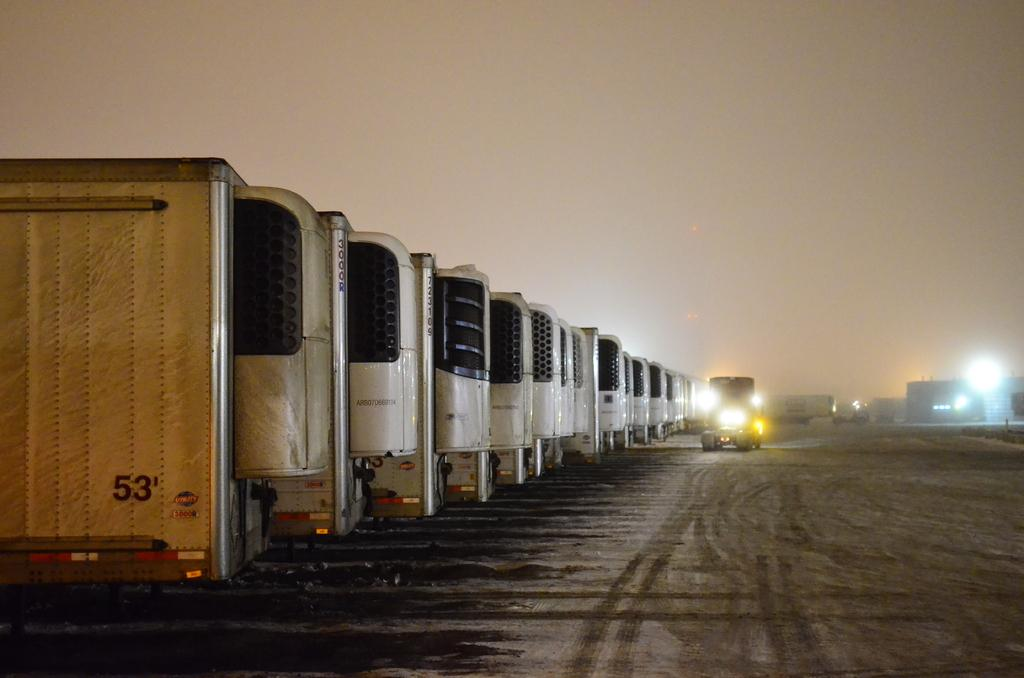What type of vehicles can be seen in the image? There are trucks in the image. What can be seen in the distance behind the trucks? There are buildings and lights in the background of the image. What is visible at the top of the image? The sky is visible at the top of the image. What type of terrain is at the bottom of the image? There is sand at the bottom of the image. What type of quill is being used to write on the sand in the image? There is no quill present in the image, and no writing on the sand is visible. 